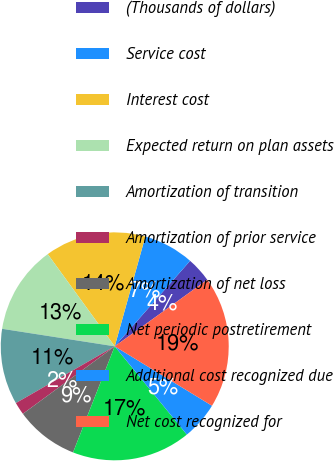Convert chart. <chart><loc_0><loc_0><loc_500><loc_500><pie_chart><fcel>(Thousands of dollars)<fcel>Service cost<fcel>Interest cost<fcel>Expected return on plan assets<fcel>Amortization of transition<fcel>Amortization of prior service<fcel>Amortization of net loss<fcel>Net periodic postretirement<fcel>Additional cost recognized due<fcel>Net cost recognized for<nl><fcel>3.58%<fcel>7.17%<fcel>14.33%<fcel>12.54%<fcel>10.75%<fcel>1.79%<fcel>8.96%<fcel>16.86%<fcel>5.37%<fcel>18.65%<nl></chart> 